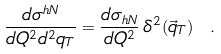Convert formula to latex. <formula><loc_0><loc_0><loc_500><loc_500>\frac { d \sigma ^ { h N } } { d Q ^ { 2 } d ^ { 2 } q _ { T } } = \frac { d \sigma _ { h N } } { d Q ^ { 2 } } \, \delta ^ { 2 } ( \vec { q } _ { T } ) \ .</formula> 